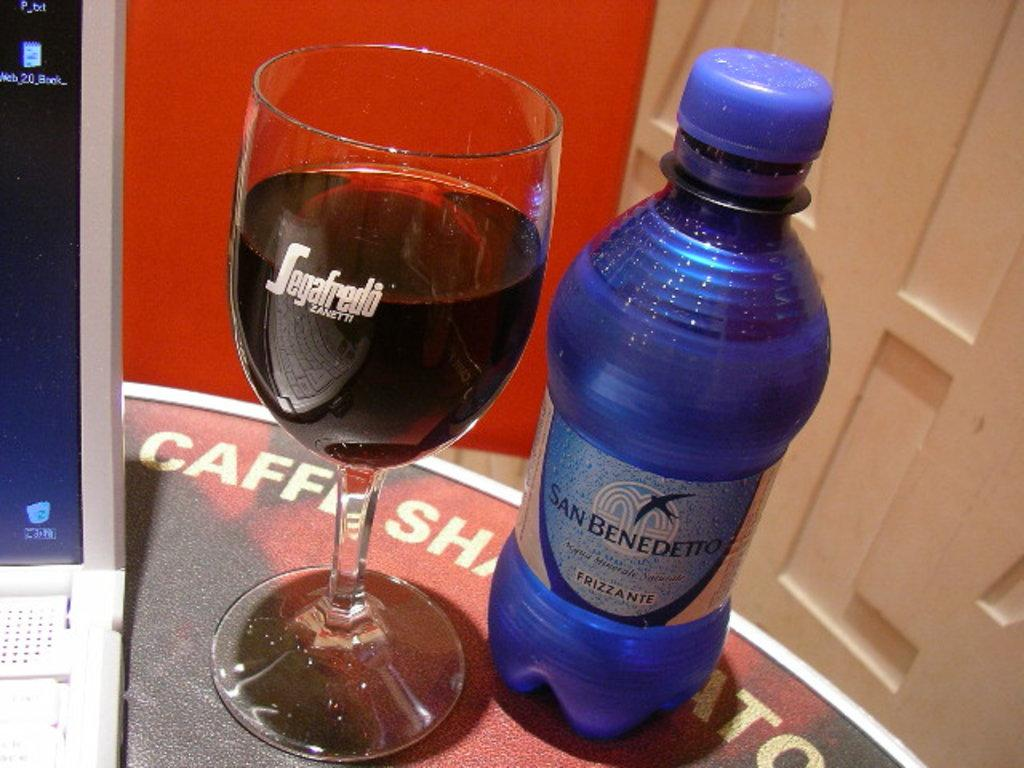What is on the table in the image? There is a bottle and a glass on the table in the image. Are the bottle and glass located together on the table? Yes, the bottle and glass are on the same table. What else can be seen near the bottle and glass? There is a laptop beside the bottle and glass. How many beds are visible in the image? There are no beds visible in the image. What type of pies are being served on the table? There are no pies present in the image. 